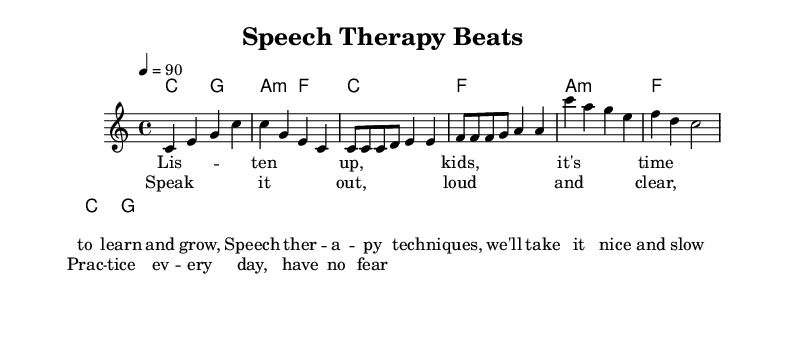What is the key signature of this music? The key signature is C major, which has no sharps or flats.
Answer: C major What is the time signature of this music? The time signature is found on the left of the staff and indicates how many beats are in each measure; here it shows 4/4, meaning there are four beats per measure.
Answer: 4/4 What is the tempo marking for this piece? The tempo marking is indicated at the beginning of the score using "=" and a number; here it specifies the beats per minute, showing the music should be played at a tempo of 90 beats per minute.
Answer: 90 How many measures are in the verse section? By counting the measures defined by the melody and the lyrics, we see that the verse spans 4 measures, as it's a partial section shown in the score.
Answer: 4 What type of music is represented here? Analyzing the lyrics, rhyme scheme, and rhythmic structure, it can be identified as "rap," which is characterized by spoken rhythmically against a background beat.
Answer: Rap Which musical element repeats in both the verse and chorus? Observing both sections, the use of rhythm and repetitive phrasing is evident; specifically, the lyrical theme about practicing and learning speech therapy techniques is echoed.
Answer: Theme 